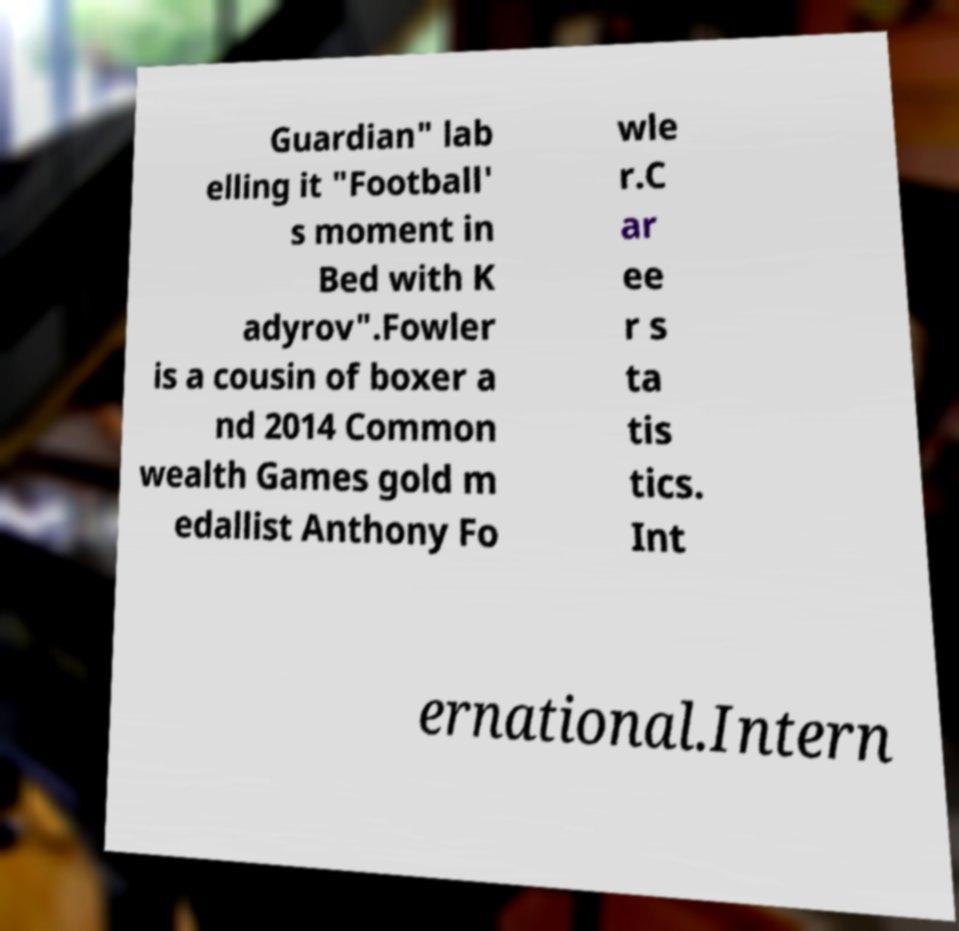Can you read and provide the text displayed in the image?This photo seems to have some interesting text. Can you extract and type it out for me? Guardian" lab elling it "Football' s moment in Bed with K adyrov".Fowler is a cousin of boxer a nd 2014 Common wealth Games gold m edallist Anthony Fo wle r.C ar ee r s ta tis tics. Int ernational.Intern 